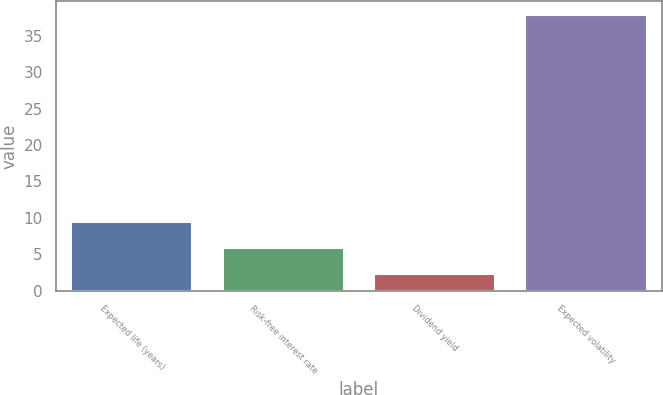Convert chart to OTSL. <chart><loc_0><loc_0><loc_500><loc_500><bar_chart><fcel>Expected life (years)<fcel>Risk-free interest rate<fcel>Dividend yield<fcel>Expected volatility<nl><fcel>9.42<fcel>5.86<fcel>2.3<fcel>37.9<nl></chart> 